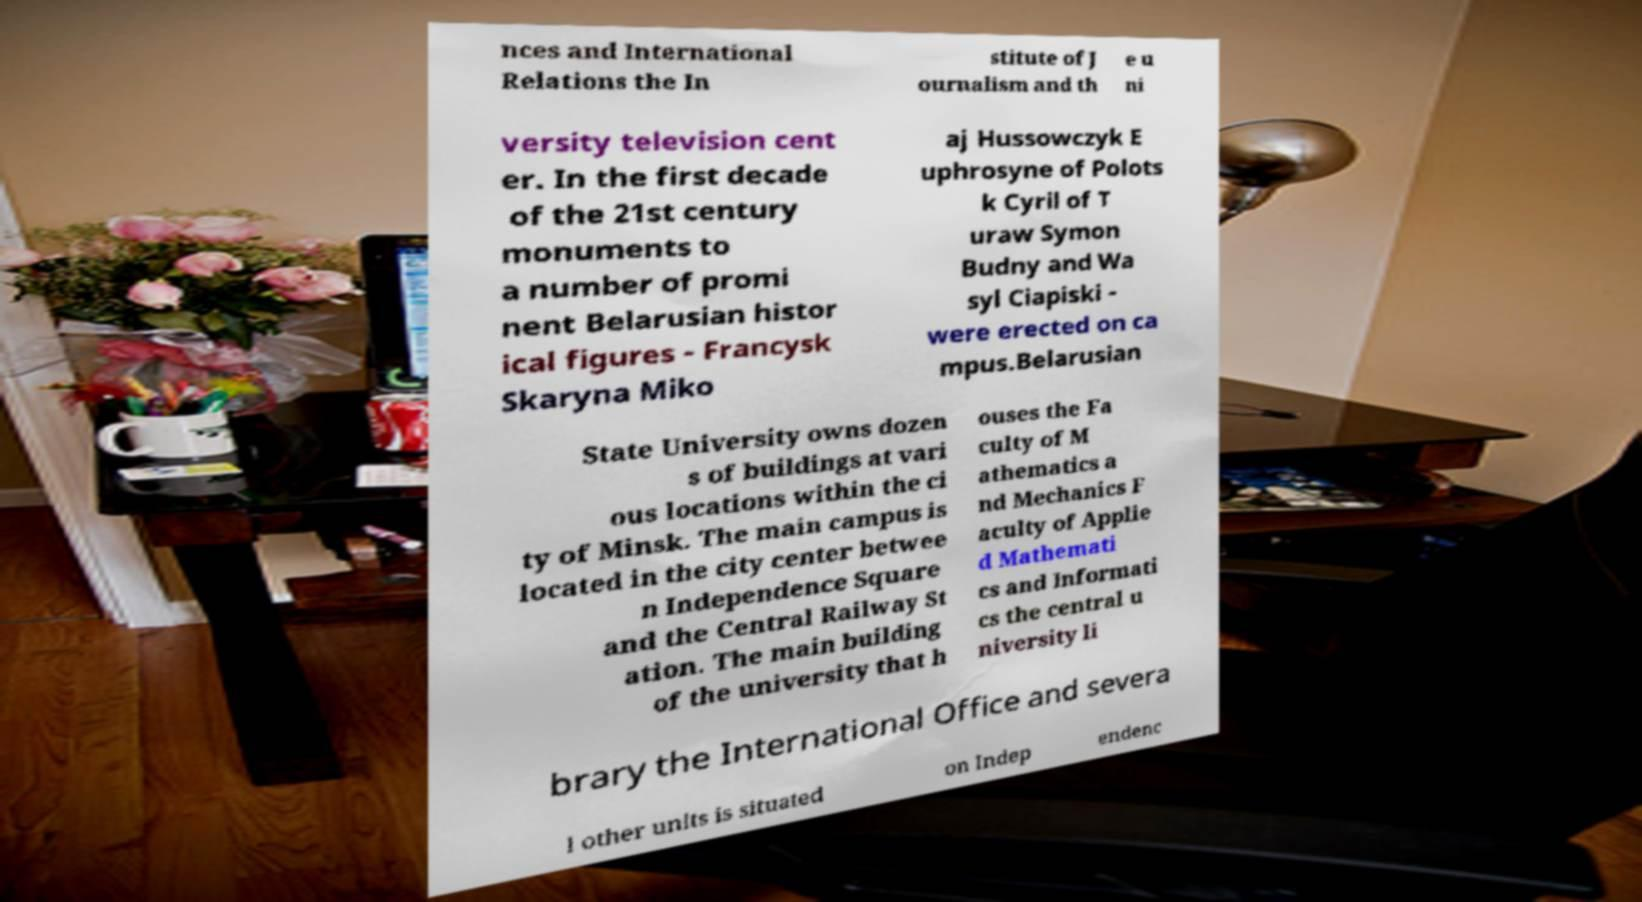Could you extract and type out the text from this image? nces and International Relations the In stitute of J ournalism and th e u ni versity television cent er. In the first decade of the 21st century monuments to a number of promi nent Belarusian histor ical figures - Francysk Skaryna Miko aj Hussowczyk E uphrosyne of Polots k Cyril of T uraw Symon Budny and Wa syl Ciapiski - were erected on ca mpus.Belarusian State University owns dozen s of buildings at vari ous locations within the ci ty of Minsk. The main campus is located in the city center betwee n Independence Square and the Central Railway St ation. The main building of the university that h ouses the Fa culty of M athematics a nd Mechanics F aculty of Applie d Mathemati cs and Informati cs the central u niversity li brary the International Office and severa l other units is situated on Indep endenc 